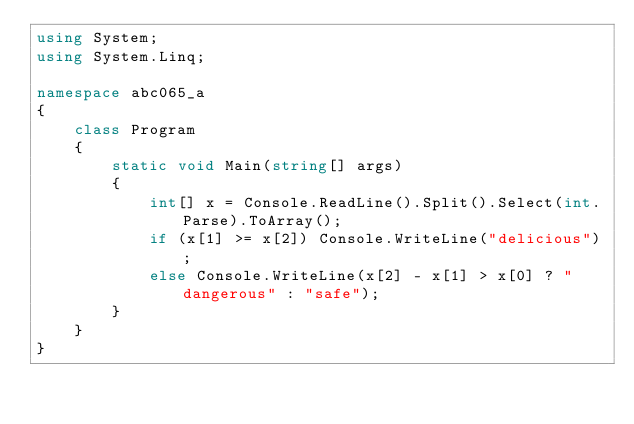Convert code to text. <code><loc_0><loc_0><loc_500><loc_500><_C#_>using System;
using System.Linq;

namespace abc065_a
{
    class Program
    {
        static void Main(string[] args)
        {
            int[] x = Console.ReadLine().Split().Select(int.Parse).ToArray();
            if (x[1] >= x[2]) Console.WriteLine("delicious");
            else Console.WriteLine(x[2] - x[1] > x[0] ? "dangerous" : "safe");
        }
    }
}</code> 